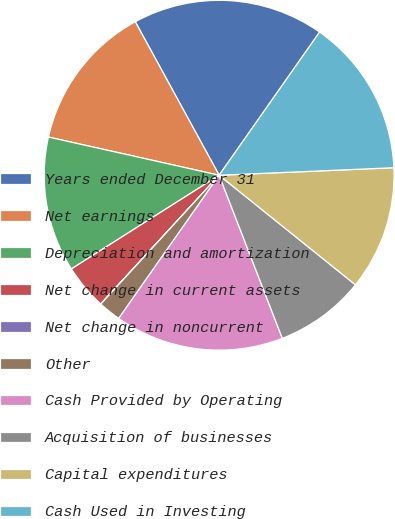Convert chart. <chart><loc_0><loc_0><loc_500><loc_500><pie_chart><fcel>Years ended December 31<fcel>Net earnings<fcel>Depreciation and amortization<fcel>Net change in current assets<fcel>Net change in noncurrent<fcel>Other<fcel>Cash Provided by Operating<fcel>Acquisition of businesses<fcel>Capital expenditures<fcel>Cash Used in Investing<nl><fcel>17.7%<fcel>13.54%<fcel>12.5%<fcel>4.17%<fcel>0.01%<fcel>2.09%<fcel>15.62%<fcel>8.34%<fcel>11.46%<fcel>14.58%<nl></chart> 